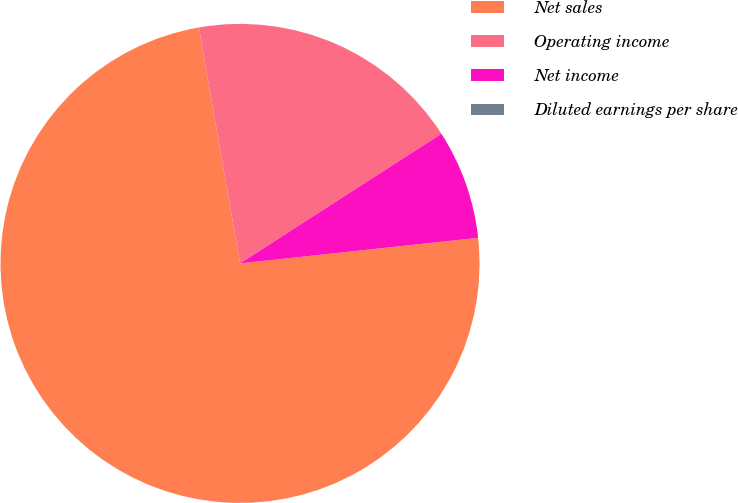Convert chart. <chart><loc_0><loc_0><loc_500><loc_500><pie_chart><fcel>Net sales<fcel>Operating income<fcel>Net income<fcel>Diluted earnings per share<nl><fcel>73.96%<fcel>18.65%<fcel>7.4%<fcel>0.0%<nl></chart> 